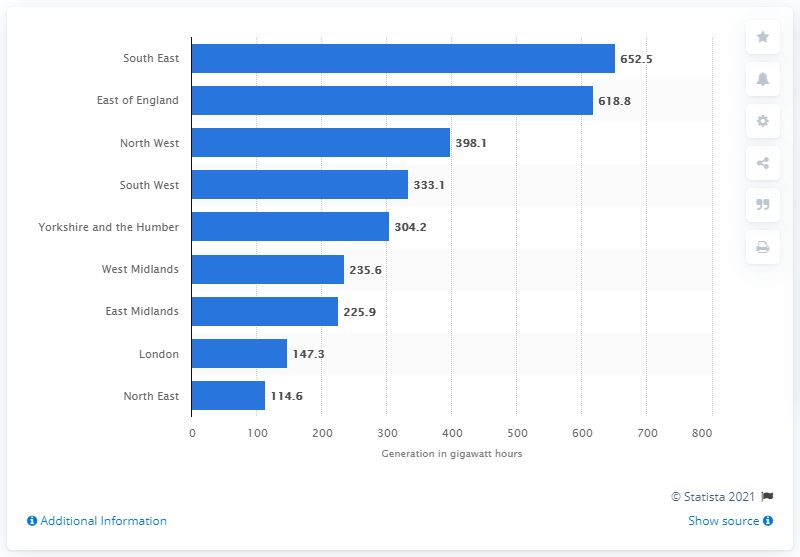List a handful of essential elements in this visual. The East of England generated the most landfill gas power generation out of all the regions in the country. The South East region of England generated the highest amount of electricity from landfill gas power in 2019, according to data. 